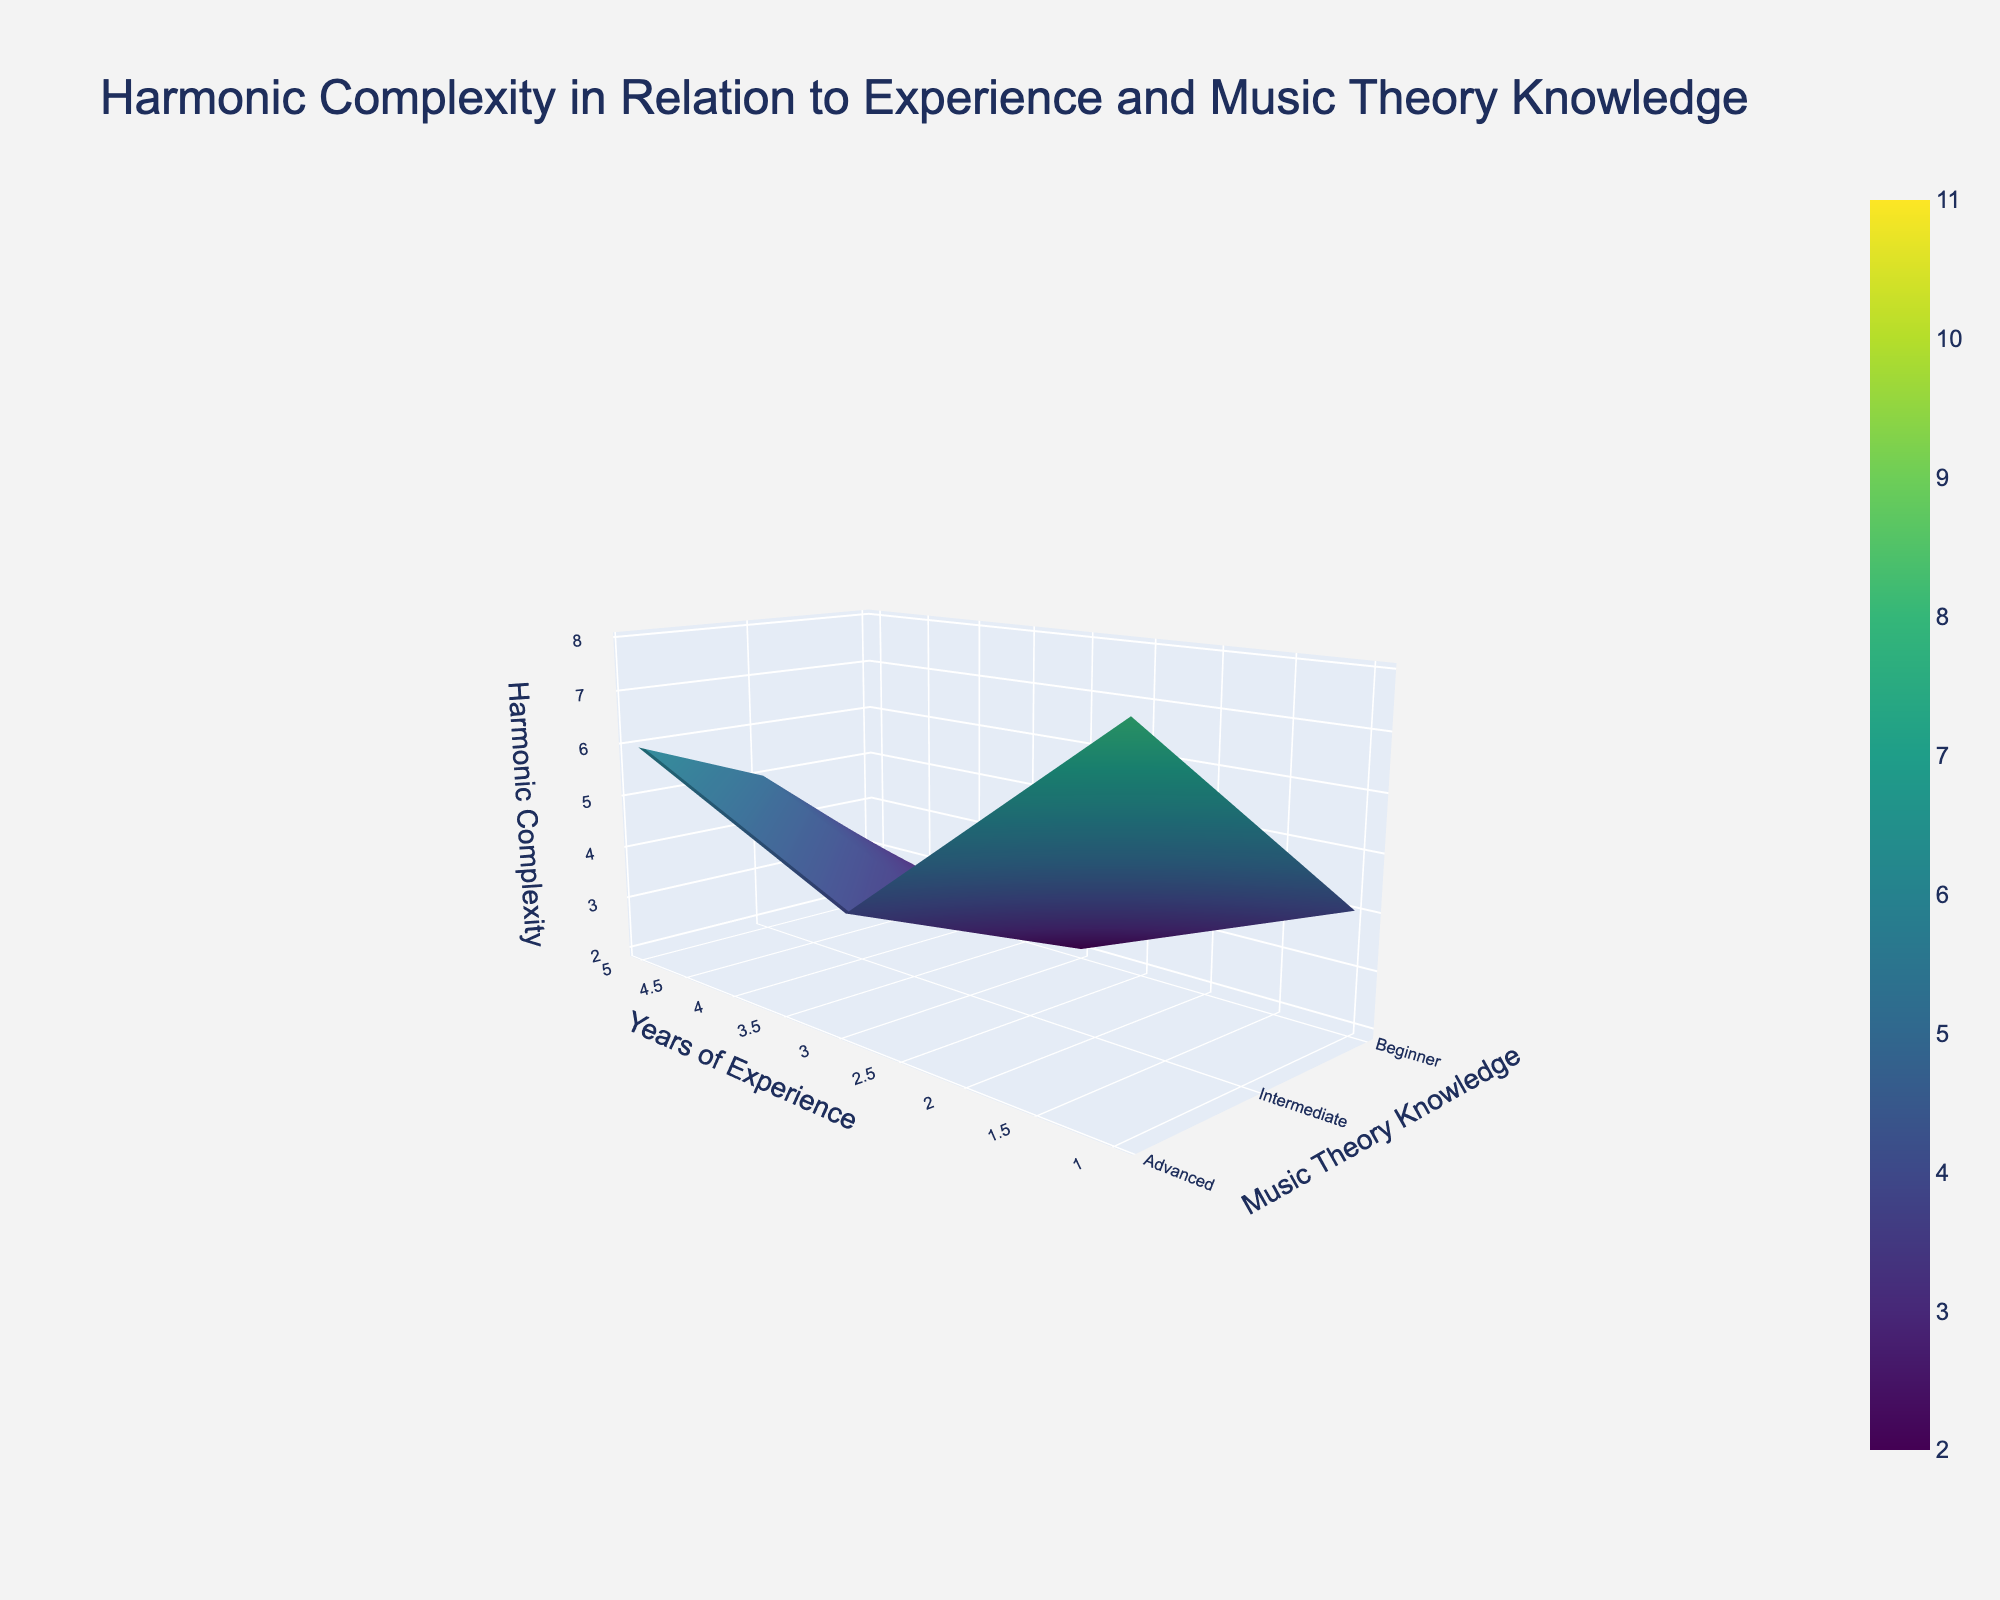What is the title of the plot? The title of the plot is usually displayed at the top. By referring to the visual information in the figure, we notice the text at the top.
Answer: Harmonic Complexity in Relation to Experience and Music Theory Knowledge What are the axes in the plot? The axes usually have labels that describe what they represent in the plot. By viewing the labels on the left and front edges of the plot, we can deduce the names.
Answer: Years of Experience, Music Theory Knowledge, Harmonic Complexity How does Harmonic Complexity change for someone with Intermediate Music Theory Knowledge as their years of experience increase from 1 to 20? By tracing along the y-axis labeled 'Intermediate' and observing the z-values as x-axis (Years of Experience) increases from 1 to 20, we can see the change in Harmonic Complexity.
Answer: From 3 to 9 What is the Harmonic Complexity for someone with 10 years of experience and Advanced Music Theory Knowledge? Locate the point on the x-axis at 10 years and on the y-axis at Advanced. The corresponding z-value represents Harmonic Complexity.
Answer: 9 Compare the Harmonic Complexity between beginners and advanced musicians with 5 years of experience. On the x-axis, find 5 years and compare the z-values for 'Beginner' and 'Advanced' on the y-axis.
Answer: Beginner: 4, Advanced: 8 What is the difference in Harmonic Complexity between a musician with 15 years of experience and Intermediate Music Theory Knowledge and one with 1 year of experience and Beginner Music Theory Knowledge? The z-values for 15 years & Intermediate are 8 and for 1 year & Beginner are 2. The difference is computed as 8 - 2.
Answer: 6 What pattern do you observe in the Harmonic Complexity as Music Theory Knowledge increases for individuals with 20 years of experience? By examining z-values for 20 years across Beginner, Intermediate, and Advanced on the y-axis, observe the trend.
Answer: Increases from 7 to 11 What is the general trend of Harmonic Complexity as Experience increases for all levels of Music Theory Knowledge? By tracing the x-axis from 1 to 20, observe how the z-values change for each level on the y-axis independently.
Answer: Increases What is the average Harmonic Complexity for musicians with 3 years of experience across all levels of Music Theory Knowledge? Sum up the z-values for 3 years across Beginner (3), Intermediate (5), and Advanced (6) and then divide by 3.
Answer: (3+5+6)/3 = 4.67 